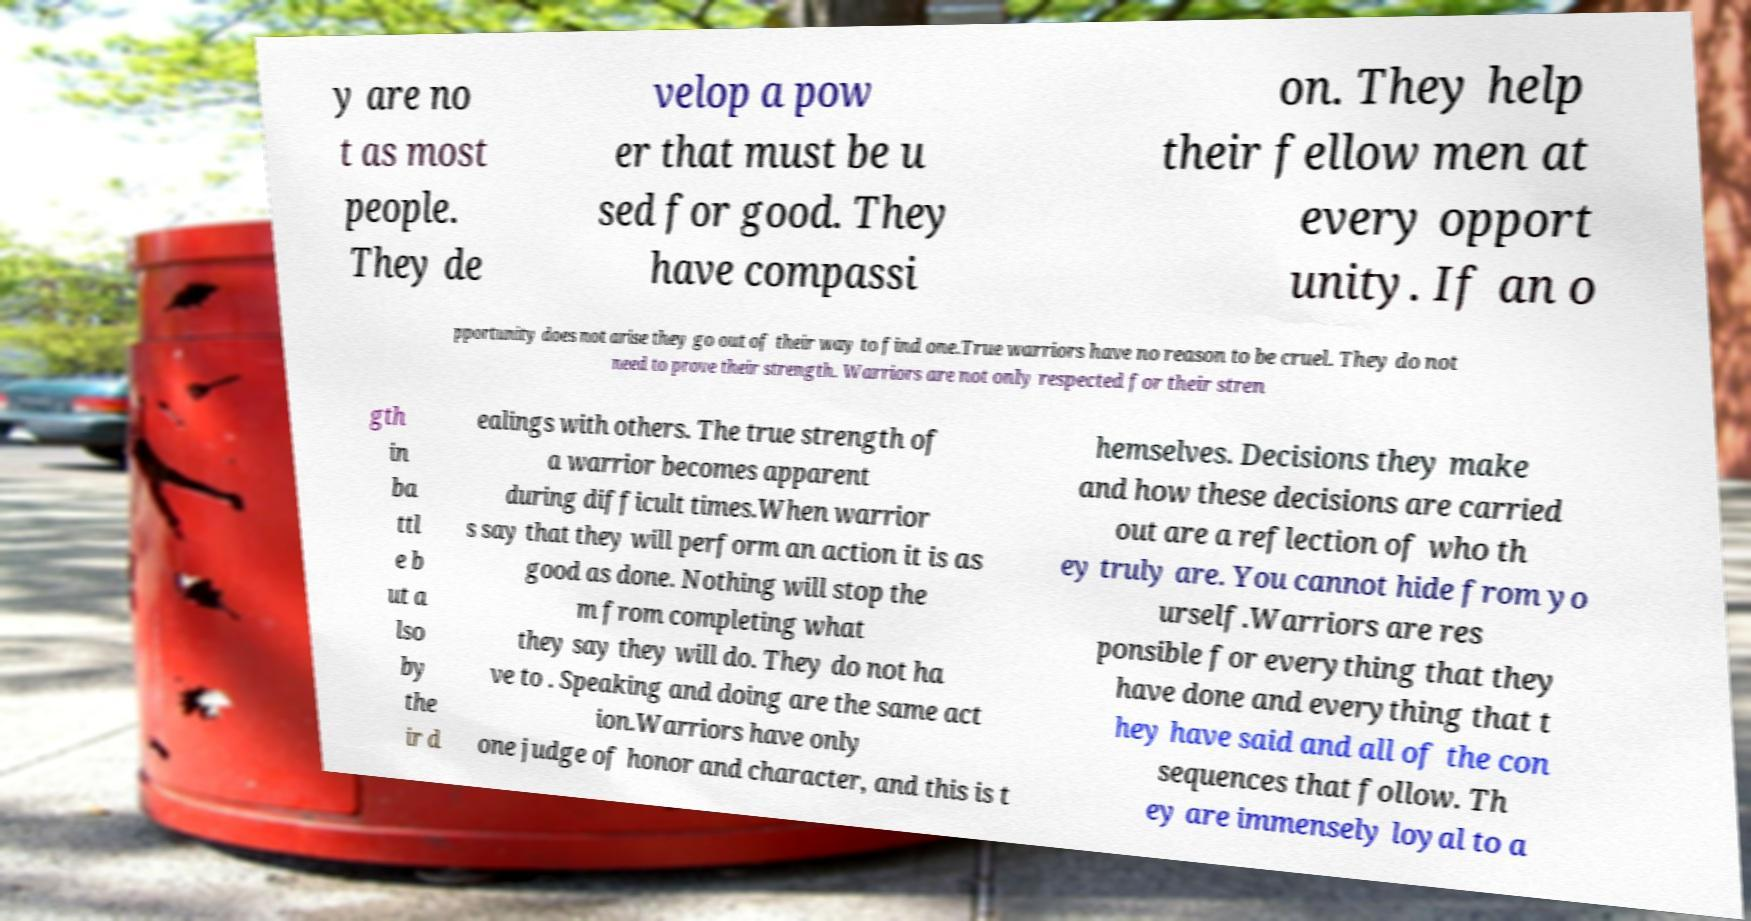For documentation purposes, I need the text within this image transcribed. Could you provide that? y are no t as most people. They de velop a pow er that must be u sed for good. They have compassi on. They help their fellow men at every opport unity. If an o pportunity does not arise they go out of their way to find one.True warriors have no reason to be cruel. They do not need to prove their strength. Warriors are not only respected for their stren gth in ba ttl e b ut a lso by the ir d ealings with others. The true strength of a warrior becomes apparent during difficult times.When warrior s say that they will perform an action it is as good as done. Nothing will stop the m from completing what they say they will do. They do not ha ve to . Speaking and doing are the same act ion.Warriors have only one judge of honor and character, and this is t hemselves. Decisions they make and how these decisions are carried out are a reflection of who th ey truly are. You cannot hide from yo urself.Warriors are res ponsible for everything that they have done and everything that t hey have said and all of the con sequences that follow. Th ey are immensely loyal to a 